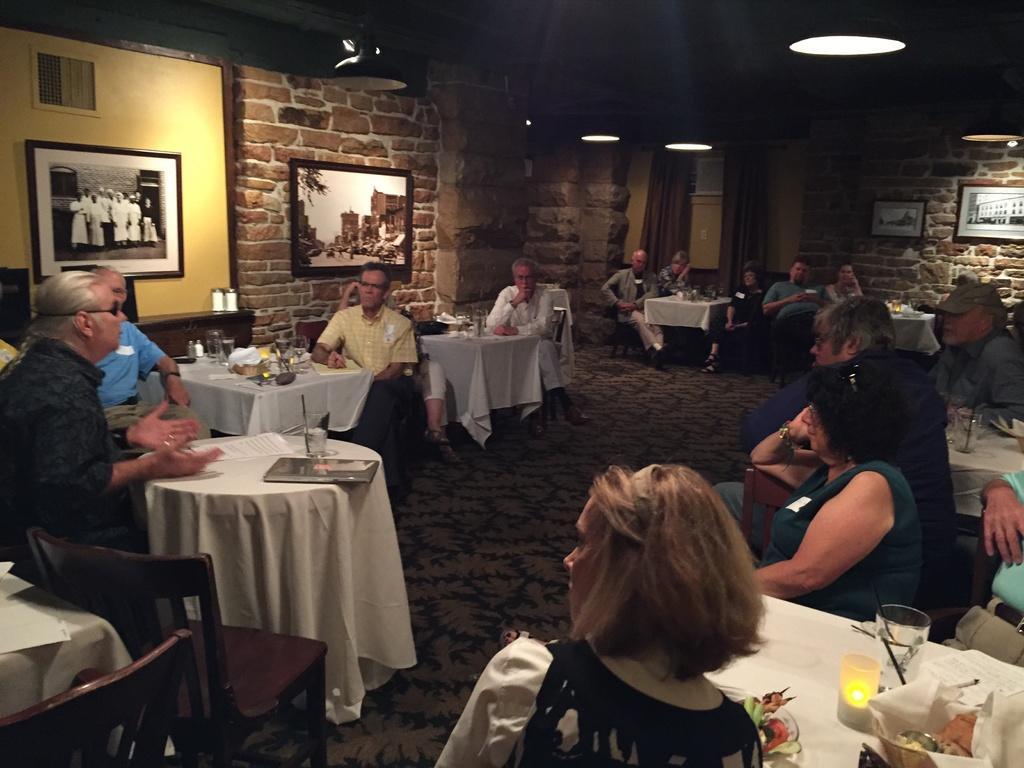How would you summarize this image in a sentence or two? The image is taken in the room. There are tables in the room and there are people sitting around the table. On the tables there are bottles, glasses, trays, food placed on the tables. In the background there is a brick wall ,photo frames attached to the wall. At the top there are lights. 